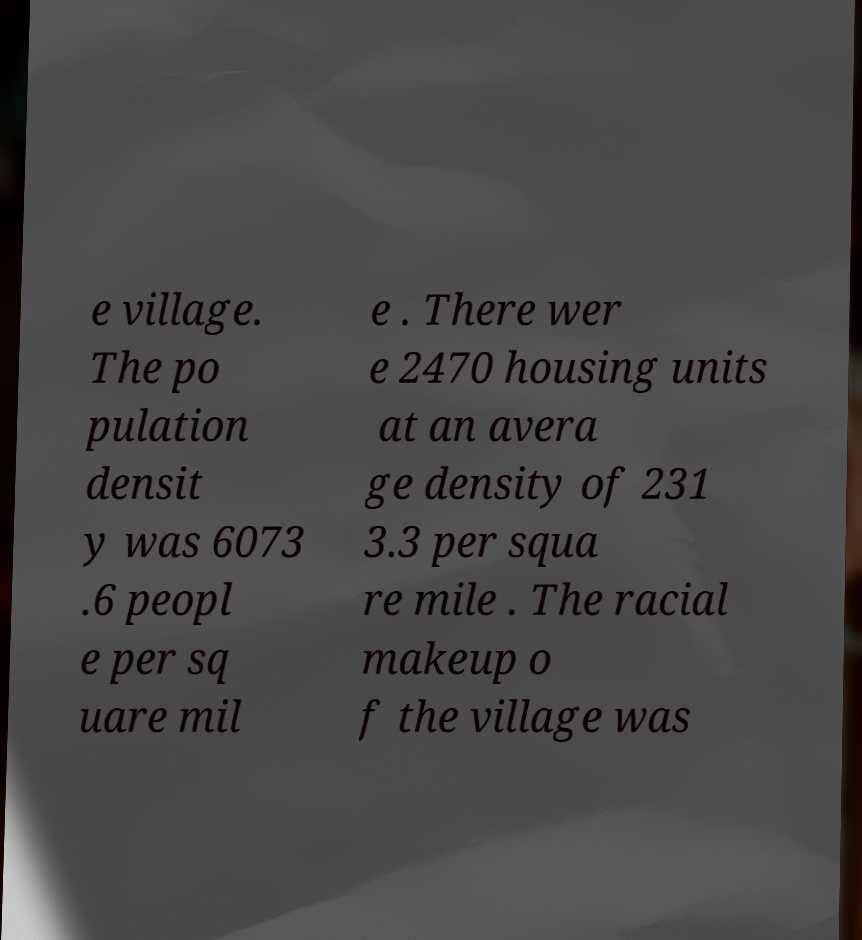I need the written content from this picture converted into text. Can you do that? e village. The po pulation densit y was 6073 .6 peopl e per sq uare mil e . There wer e 2470 housing units at an avera ge density of 231 3.3 per squa re mile . The racial makeup o f the village was 